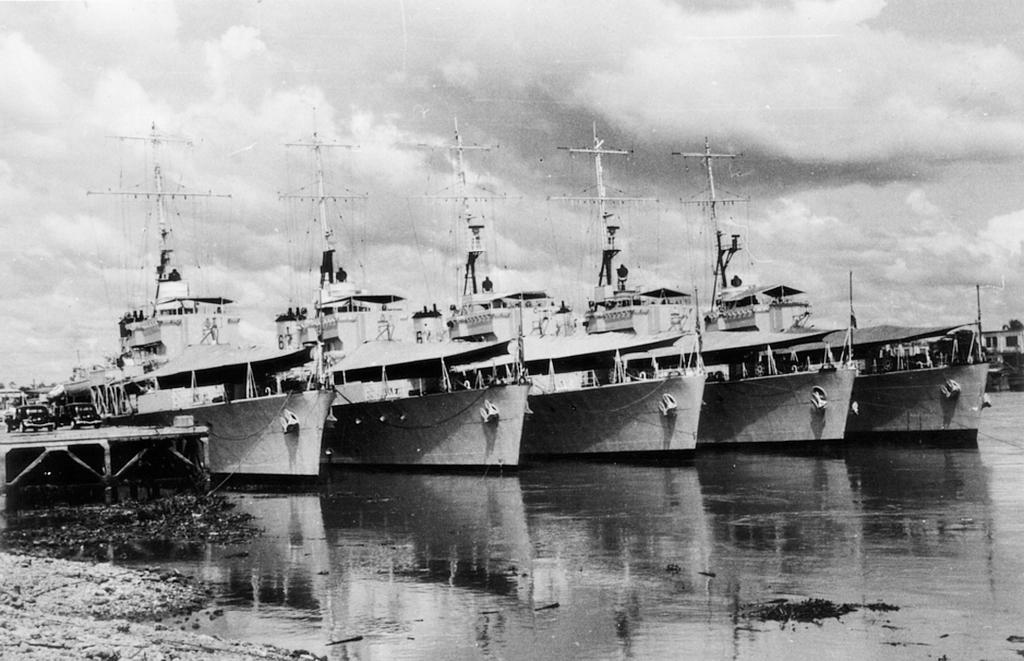In one or two sentences, can you explain what this image depicts? In this image we can see the ships on the surface of the water. On the left we can see the vehicles on the wooden platform and in the background we can see the cloudy sky and it is a black and white image. 